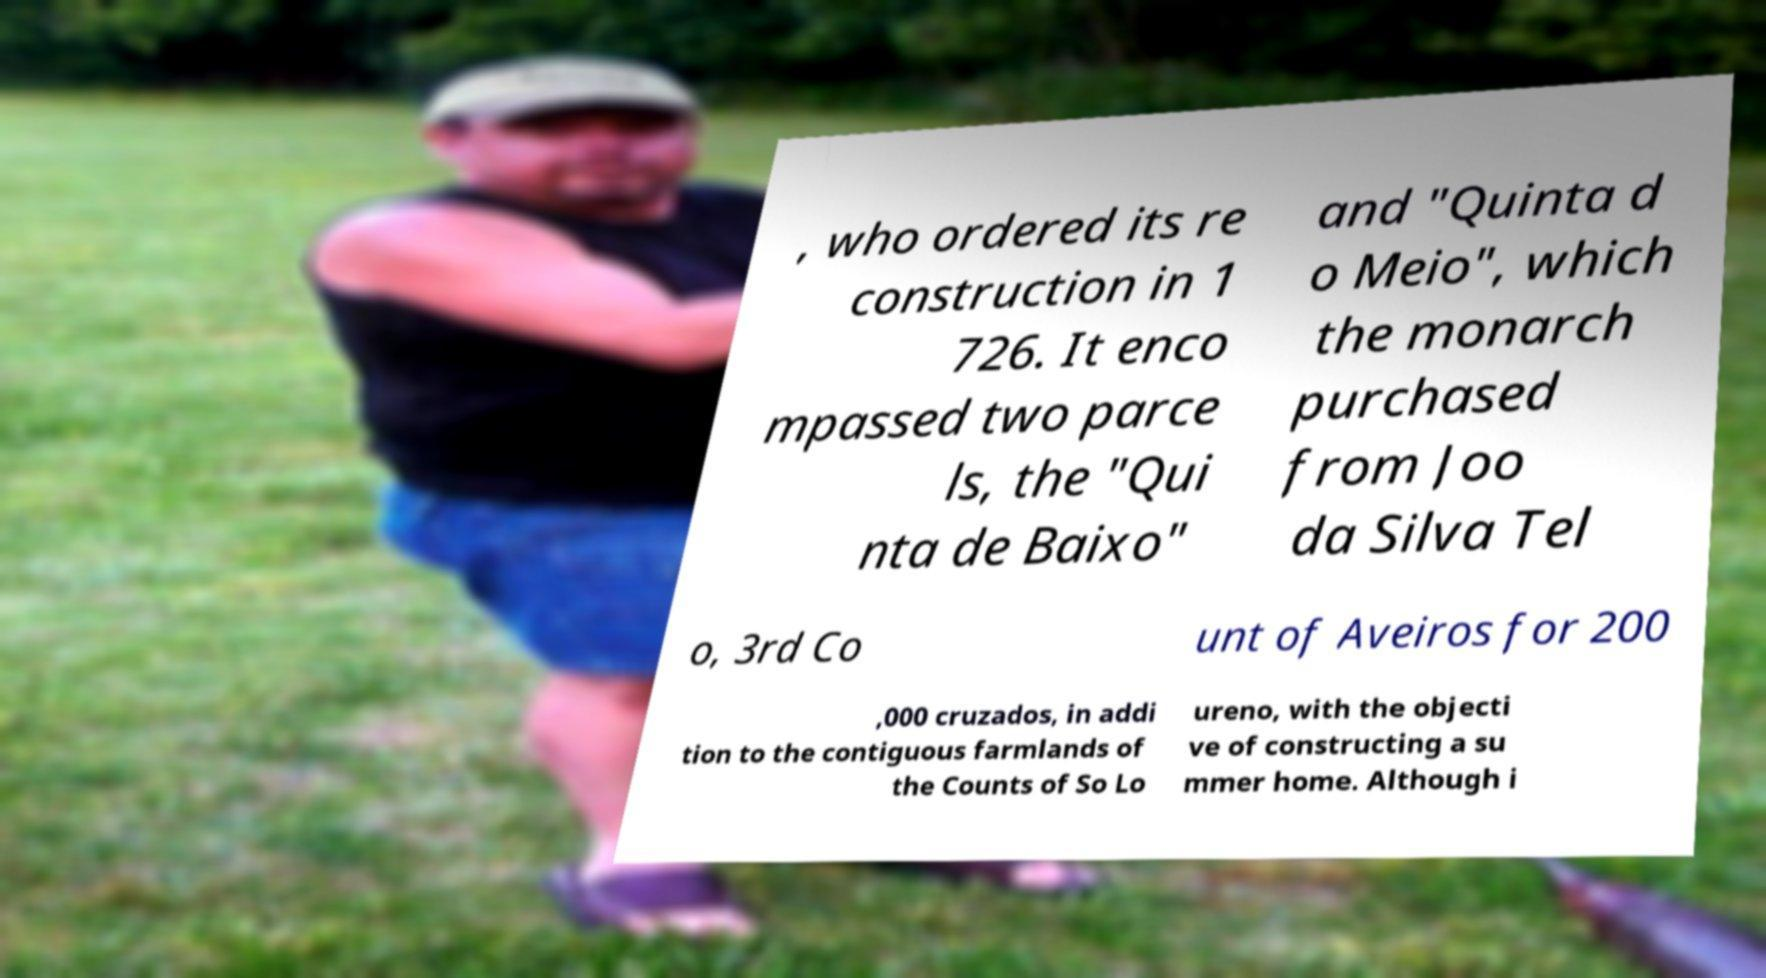Could you assist in decoding the text presented in this image and type it out clearly? , who ordered its re construction in 1 726. It enco mpassed two parce ls, the "Qui nta de Baixo" and "Quinta d o Meio", which the monarch purchased from Joo da Silva Tel o, 3rd Co unt of Aveiros for 200 ,000 cruzados, in addi tion to the contiguous farmlands of the Counts of So Lo ureno, with the objecti ve of constructing a su mmer home. Although i 